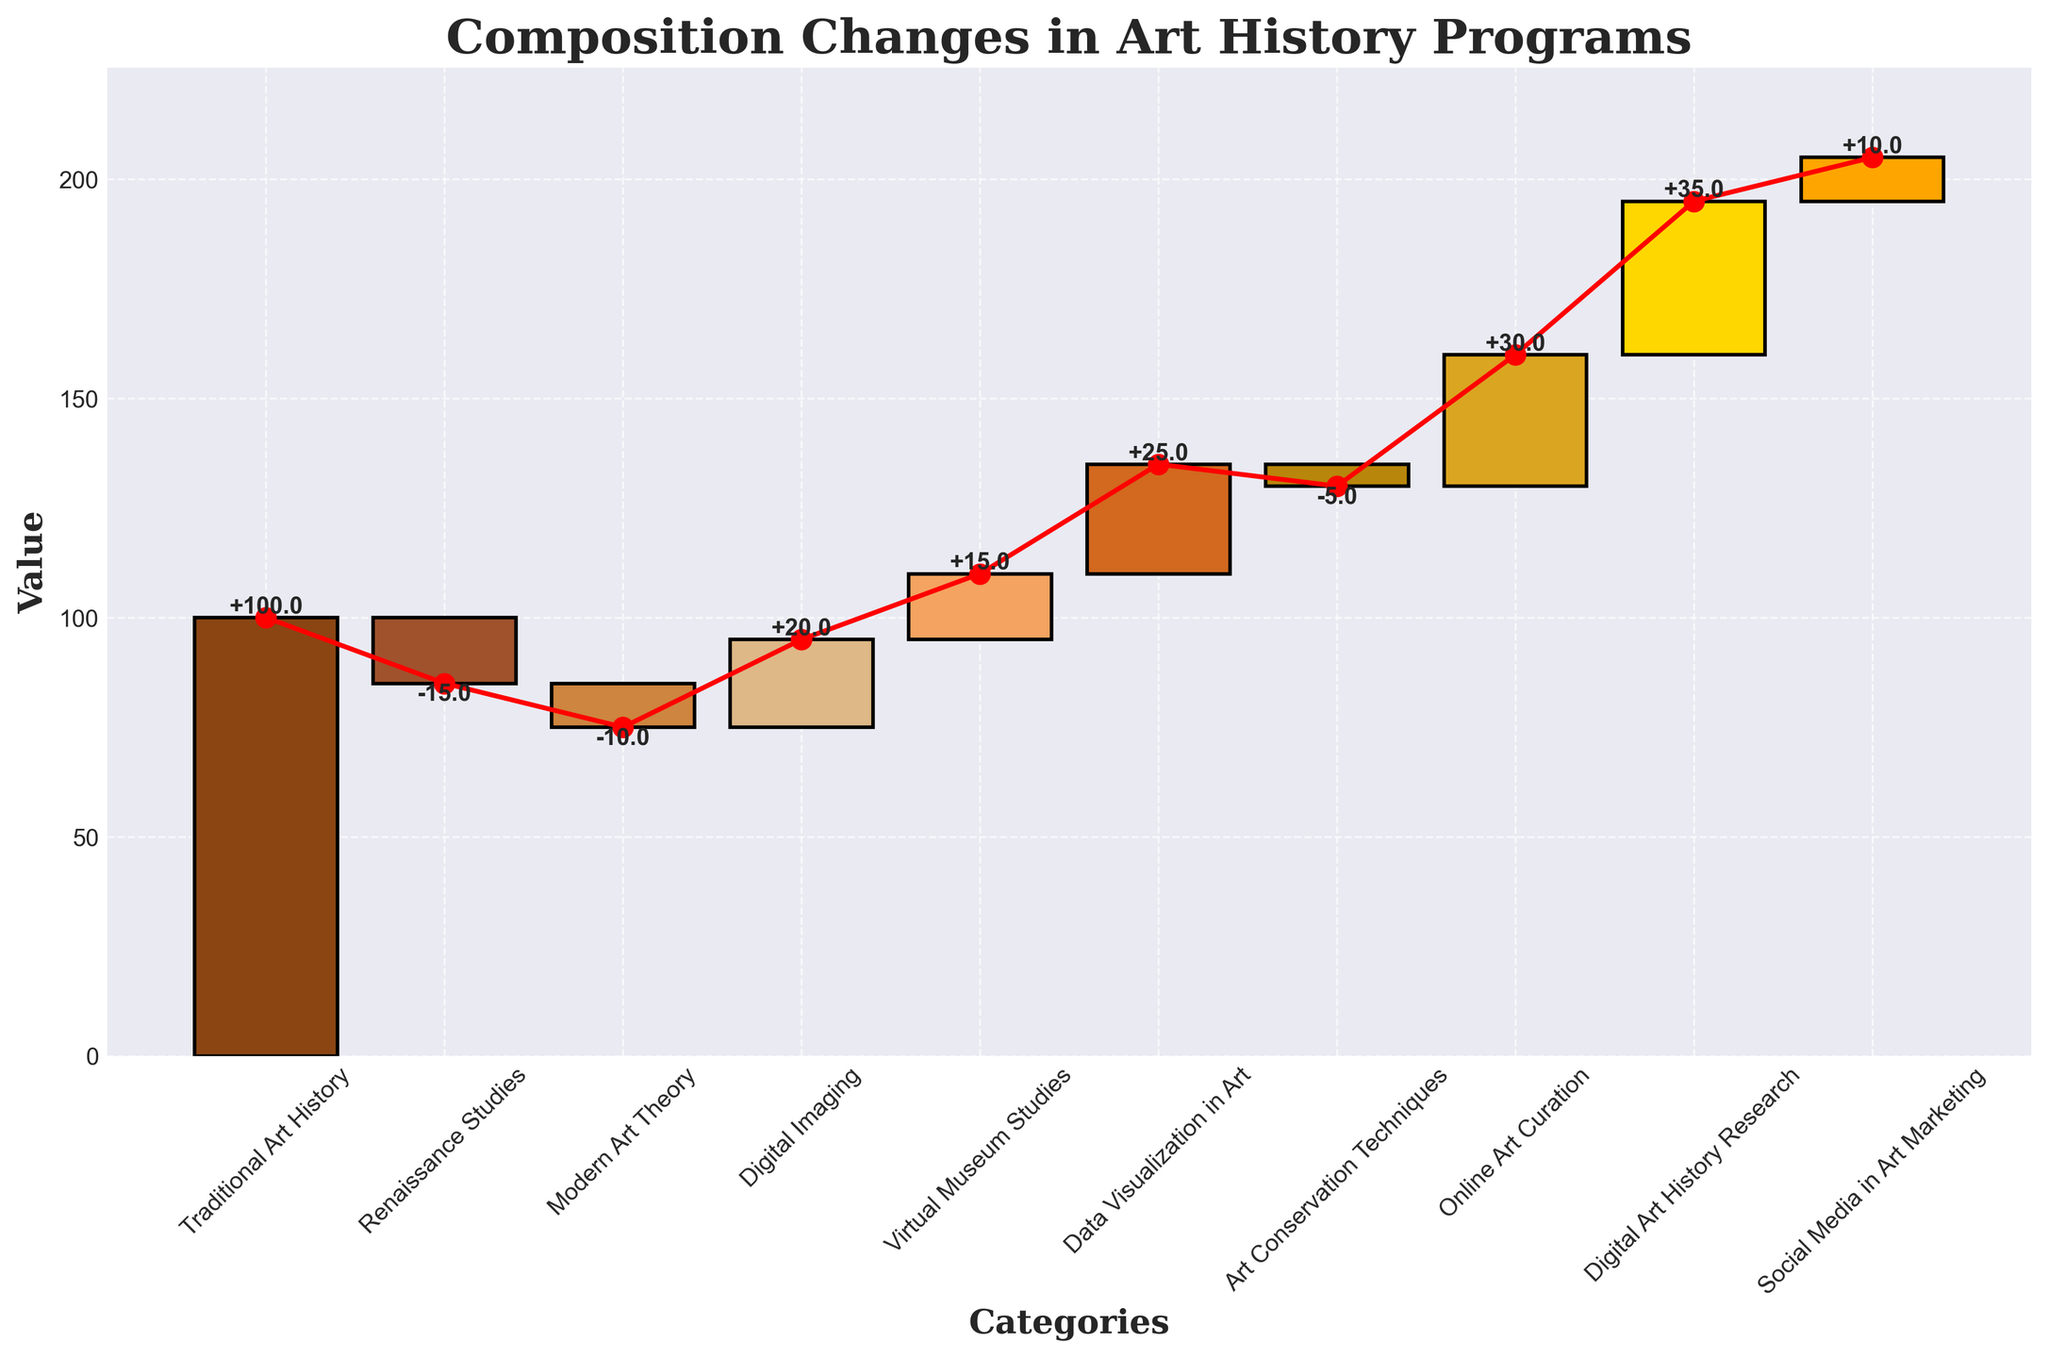what is the total value in the final step? The final step in the waterfall chart shows the total value, which is labeled at the end of the cumulative line. The value is clearly marked beside "Total".
Answer: 205 What is the title of the chart? The title of the chart is displayed at the top, usually in a larger and bolder font compared to other text.
Answer: Composition Changes in Art History Programs Which category has contributed the most significant increase? By examining the height and label of each bar that represents an increase, the largest increase figure is compared.
Answer: Digital Art History Research How many categories have negative values? Count the bars that are moving downward from the previous cumulative value, indicating a decrease. The categories with negative changes can be identified by their negative labels.
Answer: Three What is the combined decrease from Art Conservation Techniques and Renaissance Studies? Add the negative values from these two categories: -15 (Renaissance Studies) and -5 (Art Conservation Techniques). The sum is -20.
Answer: -20 What is the cumulative value after adding Digital Imaging? Start with the first entry (Traditional Art History: 100) and sequentially add the changes until Digital Imaging: 100 + (-15) + (-10) + 20 = 95.
Answer: 95 How does the contribution of Modern Art Theory compare to Data Visualization in Art? Compare the values of Modern Art Theory (-10) and Data Visualization in Art (+25). Note the positive or negative contribution by the same logical comparison of numerical value increments or decrements.
Answer: Data Visualization in Art Which categories contributed to the final value exceeding the initial value? Identify the categories with positive values to see the net gain contributions: Digital Imaging, Virtual Museum Studies, Data Visualization in Art, Online Art Curation, Digital Art History Research, and Social Media in Art Marketing.
Answer: Six categories What is the trend in value after adding Virtual Museum Studies? Calculate starting from Traditional Art History and through subsequent additions until Virtual Museum Studies: 100 + (-15) + (-10) + 20 + 15 = 110.
Answer: 110 Which category is directly responsible for surpassing the cumulative value of 200? Track the cumulative value increments until it surpasses 200. This occurs when Digital Art History Research is added, leading from 175 to 210.
Answer: Digital Art History Research 